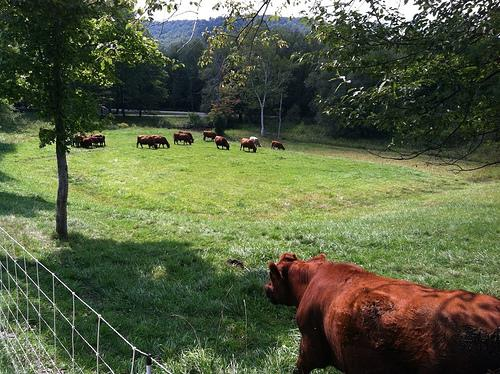Count the number of cows and trees present in the image. There are six cows and three trees in the image. What type of area are the group of animals standing in? The group of animals is standing in a green meadow with lush grass. Provide a summary of the overall scene in the image. The image depicts a group of cows grazing on green grass, surrounded by a thin metal fence, a few trees with varying leaves and branches, and a road near a field. What is the shape and color of the fence surrounding the animals? The fence is thin and made of metal wire. It is white in color. Explain the state and color of the grass in the image. The grass is green, lush, and short. What are some visual elements in the sky and the ground within the image? There is a shadow on the ground, and the sky is visible above it. Describe the main tree in the image, including its height and foliage. The main tree is tall with thick foliage and green leaves. The tree trunk is short and white. What is the activity of the cows and their position in relation to each other? The cows are grazing and standing close together in a group. Identify the primary animal in the scene and describe its appearance. The primary animal is a reddish-brown cow with dirty fur, standing alone and grazing within the herd. What type of fencing is near the primary animal in the image? The fence near the primary animal is a short, white, thin metal fence made from wire. 